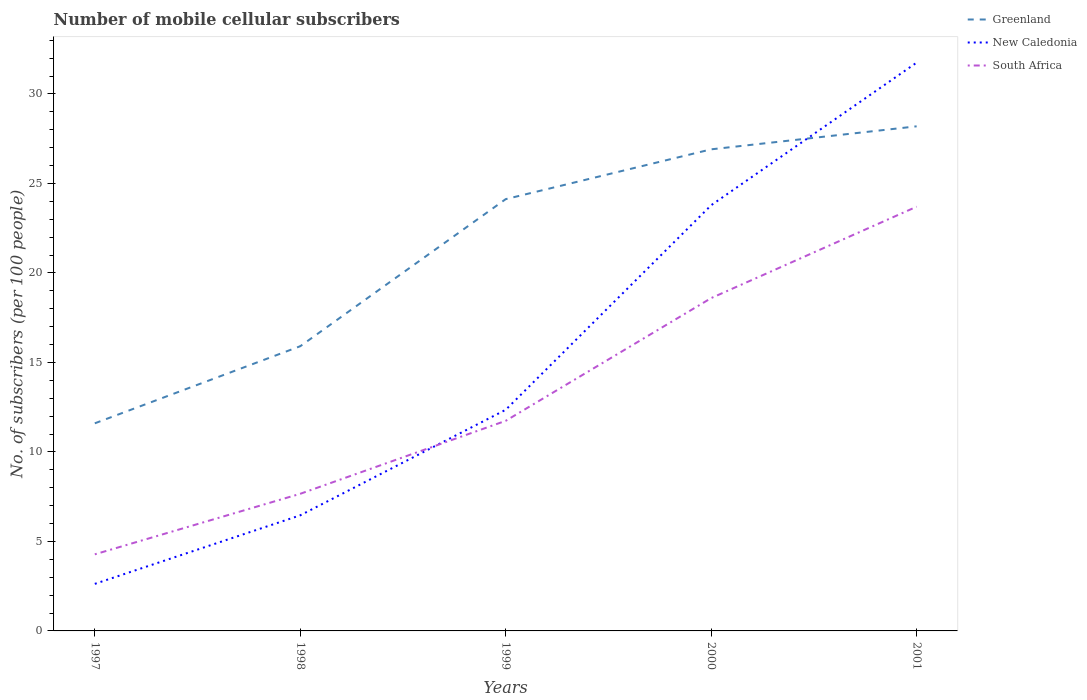Does the line corresponding to South Africa intersect with the line corresponding to Greenland?
Provide a short and direct response. No. Is the number of lines equal to the number of legend labels?
Your response must be concise. Yes. Across all years, what is the maximum number of mobile cellular subscribers in New Caledonia?
Ensure brevity in your answer.  2.63. In which year was the number of mobile cellular subscribers in South Africa maximum?
Ensure brevity in your answer.  1997. What is the total number of mobile cellular subscribers in Greenland in the graph?
Your answer should be very brief. -12.52. What is the difference between the highest and the second highest number of mobile cellular subscribers in New Caledonia?
Ensure brevity in your answer.  29.12. Is the number of mobile cellular subscribers in South Africa strictly greater than the number of mobile cellular subscribers in Greenland over the years?
Provide a short and direct response. Yes. How many lines are there?
Your answer should be very brief. 3. How many years are there in the graph?
Make the answer very short. 5. Are the values on the major ticks of Y-axis written in scientific E-notation?
Your response must be concise. No. Does the graph contain any zero values?
Give a very brief answer. No. Does the graph contain grids?
Offer a terse response. No. How are the legend labels stacked?
Offer a terse response. Vertical. What is the title of the graph?
Keep it short and to the point. Number of mobile cellular subscribers. Does "Chad" appear as one of the legend labels in the graph?
Offer a very short reply. No. What is the label or title of the X-axis?
Your answer should be compact. Years. What is the label or title of the Y-axis?
Your response must be concise. No. of subscribers (per 100 people). What is the No. of subscribers (per 100 people) of Greenland in 1997?
Your answer should be compact. 11.6. What is the No. of subscribers (per 100 people) of New Caledonia in 1997?
Provide a short and direct response. 2.63. What is the No. of subscribers (per 100 people) of South Africa in 1997?
Provide a short and direct response. 4.28. What is the No. of subscribers (per 100 people) in Greenland in 1998?
Your answer should be very brief. 15.91. What is the No. of subscribers (per 100 people) of New Caledonia in 1998?
Your answer should be compact. 6.46. What is the No. of subscribers (per 100 people) in South Africa in 1998?
Provide a short and direct response. 7.66. What is the No. of subscribers (per 100 people) of Greenland in 1999?
Offer a terse response. 24.12. What is the No. of subscribers (per 100 people) in New Caledonia in 1999?
Give a very brief answer. 12.35. What is the No. of subscribers (per 100 people) of South Africa in 1999?
Your response must be concise. 11.74. What is the No. of subscribers (per 100 people) of Greenland in 2000?
Make the answer very short. 26.91. What is the No. of subscribers (per 100 people) in New Caledonia in 2000?
Provide a short and direct response. 23.78. What is the No. of subscribers (per 100 people) in South Africa in 2000?
Make the answer very short. 18.59. What is the No. of subscribers (per 100 people) in Greenland in 2001?
Give a very brief answer. 28.19. What is the No. of subscribers (per 100 people) of New Caledonia in 2001?
Provide a short and direct response. 31.75. What is the No. of subscribers (per 100 people) of South Africa in 2001?
Offer a terse response. 23.7. Across all years, what is the maximum No. of subscribers (per 100 people) of Greenland?
Provide a short and direct response. 28.19. Across all years, what is the maximum No. of subscribers (per 100 people) of New Caledonia?
Your response must be concise. 31.75. Across all years, what is the maximum No. of subscribers (per 100 people) in South Africa?
Give a very brief answer. 23.7. Across all years, what is the minimum No. of subscribers (per 100 people) of Greenland?
Give a very brief answer. 11.6. Across all years, what is the minimum No. of subscribers (per 100 people) of New Caledonia?
Ensure brevity in your answer.  2.63. Across all years, what is the minimum No. of subscribers (per 100 people) of South Africa?
Ensure brevity in your answer.  4.28. What is the total No. of subscribers (per 100 people) in Greenland in the graph?
Provide a succinct answer. 106.72. What is the total No. of subscribers (per 100 people) in New Caledonia in the graph?
Ensure brevity in your answer.  76.97. What is the total No. of subscribers (per 100 people) in South Africa in the graph?
Provide a succinct answer. 65.97. What is the difference between the No. of subscribers (per 100 people) in Greenland in 1997 and that in 1998?
Ensure brevity in your answer.  -4.31. What is the difference between the No. of subscribers (per 100 people) of New Caledonia in 1997 and that in 1998?
Provide a succinct answer. -3.83. What is the difference between the No. of subscribers (per 100 people) of South Africa in 1997 and that in 1998?
Provide a short and direct response. -3.38. What is the difference between the No. of subscribers (per 100 people) of Greenland in 1997 and that in 1999?
Keep it short and to the point. -12.52. What is the difference between the No. of subscribers (per 100 people) in New Caledonia in 1997 and that in 1999?
Keep it short and to the point. -9.73. What is the difference between the No. of subscribers (per 100 people) of South Africa in 1997 and that in 1999?
Your answer should be very brief. -7.46. What is the difference between the No. of subscribers (per 100 people) of Greenland in 1997 and that in 2000?
Make the answer very short. -15.31. What is the difference between the No. of subscribers (per 100 people) in New Caledonia in 1997 and that in 2000?
Keep it short and to the point. -21.15. What is the difference between the No. of subscribers (per 100 people) in South Africa in 1997 and that in 2000?
Keep it short and to the point. -14.32. What is the difference between the No. of subscribers (per 100 people) in Greenland in 1997 and that in 2001?
Ensure brevity in your answer.  -16.59. What is the difference between the No. of subscribers (per 100 people) in New Caledonia in 1997 and that in 2001?
Provide a short and direct response. -29.12. What is the difference between the No. of subscribers (per 100 people) of South Africa in 1997 and that in 2001?
Your response must be concise. -19.42. What is the difference between the No. of subscribers (per 100 people) of Greenland in 1998 and that in 1999?
Offer a very short reply. -8.22. What is the difference between the No. of subscribers (per 100 people) in New Caledonia in 1998 and that in 1999?
Make the answer very short. -5.9. What is the difference between the No. of subscribers (per 100 people) of South Africa in 1998 and that in 1999?
Make the answer very short. -4.08. What is the difference between the No. of subscribers (per 100 people) of Greenland in 1998 and that in 2000?
Offer a terse response. -11. What is the difference between the No. of subscribers (per 100 people) of New Caledonia in 1998 and that in 2000?
Your answer should be very brief. -17.32. What is the difference between the No. of subscribers (per 100 people) in South Africa in 1998 and that in 2000?
Ensure brevity in your answer.  -10.93. What is the difference between the No. of subscribers (per 100 people) of Greenland in 1998 and that in 2001?
Keep it short and to the point. -12.29. What is the difference between the No. of subscribers (per 100 people) in New Caledonia in 1998 and that in 2001?
Provide a short and direct response. -25.29. What is the difference between the No. of subscribers (per 100 people) of South Africa in 1998 and that in 2001?
Make the answer very short. -16.04. What is the difference between the No. of subscribers (per 100 people) in Greenland in 1999 and that in 2000?
Give a very brief answer. -2.78. What is the difference between the No. of subscribers (per 100 people) in New Caledonia in 1999 and that in 2000?
Ensure brevity in your answer.  -11.43. What is the difference between the No. of subscribers (per 100 people) in South Africa in 1999 and that in 2000?
Offer a terse response. -6.86. What is the difference between the No. of subscribers (per 100 people) in Greenland in 1999 and that in 2001?
Your answer should be compact. -4.07. What is the difference between the No. of subscribers (per 100 people) in New Caledonia in 1999 and that in 2001?
Ensure brevity in your answer.  -19.39. What is the difference between the No. of subscribers (per 100 people) in South Africa in 1999 and that in 2001?
Offer a terse response. -11.96. What is the difference between the No. of subscribers (per 100 people) in Greenland in 2000 and that in 2001?
Your response must be concise. -1.29. What is the difference between the No. of subscribers (per 100 people) in New Caledonia in 2000 and that in 2001?
Make the answer very short. -7.97. What is the difference between the No. of subscribers (per 100 people) of South Africa in 2000 and that in 2001?
Your answer should be very brief. -5.11. What is the difference between the No. of subscribers (per 100 people) of Greenland in 1997 and the No. of subscribers (per 100 people) of New Caledonia in 1998?
Your answer should be very brief. 5.14. What is the difference between the No. of subscribers (per 100 people) of Greenland in 1997 and the No. of subscribers (per 100 people) of South Africa in 1998?
Provide a short and direct response. 3.94. What is the difference between the No. of subscribers (per 100 people) in New Caledonia in 1997 and the No. of subscribers (per 100 people) in South Africa in 1998?
Offer a terse response. -5.03. What is the difference between the No. of subscribers (per 100 people) of Greenland in 1997 and the No. of subscribers (per 100 people) of New Caledonia in 1999?
Make the answer very short. -0.76. What is the difference between the No. of subscribers (per 100 people) of Greenland in 1997 and the No. of subscribers (per 100 people) of South Africa in 1999?
Ensure brevity in your answer.  -0.14. What is the difference between the No. of subscribers (per 100 people) of New Caledonia in 1997 and the No. of subscribers (per 100 people) of South Africa in 1999?
Give a very brief answer. -9.11. What is the difference between the No. of subscribers (per 100 people) in Greenland in 1997 and the No. of subscribers (per 100 people) in New Caledonia in 2000?
Offer a terse response. -12.18. What is the difference between the No. of subscribers (per 100 people) in Greenland in 1997 and the No. of subscribers (per 100 people) in South Africa in 2000?
Provide a short and direct response. -7. What is the difference between the No. of subscribers (per 100 people) of New Caledonia in 1997 and the No. of subscribers (per 100 people) of South Africa in 2000?
Give a very brief answer. -15.97. What is the difference between the No. of subscribers (per 100 people) of Greenland in 1997 and the No. of subscribers (per 100 people) of New Caledonia in 2001?
Your answer should be compact. -20.15. What is the difference between the No. of subscribers (per 100 people) in Greenland in 1997 and the No. of subscribers (per 100 people) in South Africa in 2001?
Ensure brevity in your answer.  -12.1. What is the difference between the No. of subscribers (per 100 people) of New Caledonia in 1997 and the No. of subscribers (per 100 people) of South Africa in 2001?
Make the answer very short. -21.07. What is the difference between the No. of subscribers (per 100 people) of Greenland in 1998 and the No. of subscribers (per 100 people) of New Caledonia in 1999?
Provide a succinct answer. 3.55. What is the difference between the No. of subscribers (per 100 people) in Greenland in 1998 and the No. of subscribers (per 100 people) in South Africa in 1999?
Offer a very short reply. 4.17. What is the difference between the No. of subscribers (per 100 people) in New Caledonia in 1998 and the No. of subscribers (per 100 people) in South Africa in 1999?
Offer a terse response. -5.28. What is the difference between the No. of subscribers (per 100 people) of Greenland in 1998 and the No. of subscribers (per 100 people) of New Caledonia in 2000?
Keep it short and to the point. -7.88. What is the difference between the No. of subscribers (per 100 people) in Greenland in 1998 and the No. of subscribers (per 100 people) in South Africa in 2000?
Provide a short and direct response. -2.69. What is the difference between the No. of subscribers (per 100 people) of New Caledonia in 1998 and the No. of subscribers (per 100 people) of South Africa in 2000?
Offer a very short reply. -12.14. What is the difference between the No. of subscribers (per 100 people) of Greenland in 1998 and the No. of subscribers (per 100 people) of New Caledonia in 2001?
Ensure brevity in your answer.  -15.84. What is the difference between the No. of subscribers (per 100 people) in Greenland in 1998 and the No. of subscribers (per 100 people) in South Africa in 2001?
Offer a very short reply. -7.79. What is the difference between the No. of subscribers (per 100 people) of New Caledonia in 1998 and the No. of subscribers (per 100 people) of South Africa in 2001?
Your answer should be very brief. -17.24. What is the difference between the No. of subscribers (per 100 people) of Greenland in 1999 and the No. of subscribers (per 100 people) of New Caledonia in 2000?
Provide a short and direct response. 0.34. What is the difference between the No. of subscribers (per 100 people) of Greenland in 1999 and the No. of subscribers (per 100 people) of South Africa in 2000?
Your response must be concise. 5.53. What is the difference between the No. of subscribers (per 100 people) of New Caledonia in 1999 and the No. of subscribers (per 100 people) of South Africa in 2000?
Your answer should be very brief. -6.24. What is the difference between the No. of subscribers (per 100 people) of Greenland in 1999 and the No. of subscribers (per 100 people) of New Caledonia in 2001?
Make the answer very short. -7.63. What is the difference between the No. of subscribers (per 100 people) in Greenland in 1999 and the No. of subscribers (per 100 people) in South Africa in 2001?
Give a very brief answer. 0.42. What is the difference between the No. of subscribers (per 100 people) of New Caledonia in 1999 and the No. of subscribers (per 100 people) of South Africa in 2001?
Your answer should be very brief. -11.35. What is the difference between the No. of subscribers (per 100 people) in Greenland in 2000 and the No. of subscribers (per 100 people) in New Caledonia in 2001?
Offer a terse response. -4.84. What is the difference between the No. of subscribers (per 100 people) of Greenland in 2000 and the No. of subscribers (per 100 people) of South Africa in 2001?
Your answer should be very brief. 3.2. What is the difference between the No. of subscribers (per 100 people) in New Caledonia in 2000 and the No. of subscribers (per 100 people) in South Africa in 2001?
Offer a very short reply. 0.08. What is the average No. of subscribers (per 100 people) of Greenland per year?
Your answer should be compact. 21.34. What is the average No. of subscribers (per 100 people) in New Caledonia per year?
Make the answer very short. 15.39. What is the average No. of subscribers (per 100 people) of South Africa per year?
Make the answer very short. 13.19. In the year 1997, what is the difference between the No. of subscribers (per 100 people) of Greenland and No. of subscribers (per 100 people) of New Caledonia?
Give a very brief answer. 8.97. In the year 1997, what is the difference between the No. of subscribers (per 100 people) in Greenland and No. of subscribers (per 100 people) in South Africa?
Your answer should be very brief. 7.32. In the year 1997, what is the difference between the No. of subscribers (per 100 people) of New Caledonia and No. of subscribers (per 100 people) of South Africa?
Provide a succinct answer. -1.65. In the year 1998, what is the difference between the No. of subscribers (per 100 people) of Greenland and No. of subscribers (per 100 people) of New Caledonia?
Provide a succinct answer. 9.45. In the year 1998, what is the difference between the No. of subscribers (per 100 people) in Greenland and No. of subscribers (per 100 people) in South Africa?
Provide a short and direct response. 8.24. In the year 1998, what is the difference between the No. of subscribers (per 100 people) of New Caledonia and No. of subscribers (per 100 people) of South Africa?
Your answer should be compact. -1.2. In the year 1999, what is the difference between the No. of subscribers (per 100 people) in Greenland and No. of subscribers (per 100 people) in New Caledonia?
Offer a terse response. 11.77. In the year 1999, what is the difference between the No. of subscribers (per 100 people) of Greenland and No. of subscribers (per 100 people) of South Africa?
Provide a succinct answer. 12.38. In the year 1999, what is the difference between the No. of subscribers (per 100 people) of New Caledonia and No. of subscribers (per 100 people) of South Africa?
Keep it short and to the point. 0.62. In the year 2000, what is the difference between the No. of subscribers (per 100 people) of Greenland and No. of subscribers (per 100 people) of New Caledonia?
Give a very brief answer. 3.12. In the year 2000, what is the difference between the No. of subscribers (per 100 people) of Greenland and No. of subscribers (per 100 people) of South Africa?
Your answer should be very brief. 8.31. In the year 2000, what is the difference between the No. of subscribers (per 100 people) of New Caledonia and No. of subscribers (per 100 people) of South Africa?
Your answer should be compact. 5.19. In the year 2001, what is the difference between the No. of subscribers (per 100 people) in Greenland and No. of subscribers (per 100 people) in New Caledonia?
Your answer should be very brief. -3.56. In the year 2001, what is the difference between the No. of subscribers (per 100 people) of Greenland and No. of subscribers (per 100 people) of South Africa?
Provide a short and direct response. 4.49. In the year 2001, what is the difference between the No. of subscribers (per 100 people) in New Caledonia and No. of subscribers (per 100 people) in South Africa?
Provide a short and direct response. 8.05. What is the ratio of the No. of subscribers (per 100 people) in Greenland in 1997 to that in 1998?
Offer a terse response. 0.73. What is the ratio of the No. of subscribers (per 100 people) of New Caledonia in 1997 to that in 1998?
Your answer should be compact. 0.41. What is the ratio of the No. of subscribers (per 100 people) in South Africa in 1997 to that in 1998?
Provide a short and direct response. 0.56. What is the ratio of the No. of subscribers (per 100 people) in Greenland in 1997 to that in 1999?
Your response must be concise. 0.48. What is the ratio of the No. of subscribers (per 100 people) of New Caledonia in 1997 to that in 1999?
Keep it short and to the point. 0.21. What is the ratio of the No. of subscribers (per 100 people) of South Africa in 1997 to that in 1999?
Give a very brief answer. 0.36. What is the ratio of the No. of subscribers (per 100 people) of Greenland in 1997 to that in 2000?
Provide a succinct answer. 0.43. What is the ratio of the No. of subscribers (per 100 people) in New Caledonia in 1997 to that in 2000?
Give a very brief answer. 0.11. What is the ratio of the No. of subscribers (per 100 people) of South Africa in 1997 to that in 2000?
Offer a very short reply. 0.23. What is the ratio of the No. of subscribers (per 100 people) in Greenland in 1997 to that in 2001?
Make the answer very short. 0.41. What is the ratio of the No. of subscribers (per 100 people) of New Caledonia in 1997 to that in 2001?
Provide a succinct answer. 0.08. What is the ratio of the No. of subscribers (per 100 people) in South Africa in 1997 to that in 2001?
Keep it short and to the point. 0.18. What is the ratio of the No. of subscribers (per 100 people) of Greenland in 1998 to that in 1999?
Provide a short and direct response. 0.66. What is the ratio of the No. of subscribers (per 100 people) in New Caledonia in 1998 to that in 1999?
Make the answer very short. 0.52. What is the ratio of the No. of subscribers (per 100 people) in South Africa in 1998 to that in 1999?
Your response must be concise. 0.65. What is the ratio of the No. of subscribers (per 100 people) in Greenland in 1998 to that in 2000?
Your answer should be compact. 0.59. What is the ratio of the No. of subscribers (per 100 people) of New Caledonia in 1998 to that in 2000?
Offer a very short reply. 0.27. What is the ratio of the No. of subscribers (per 100 people) in South Africa in 1998 to that in 2000?
Offer a terse response. 0.41. What is the ratio of the No. of subscribers (per 100 people) of Greenland in 1998 to that in 2001?
Provide a short and direct response. 0.56. What is the ratio of the No. of subscribers (per 100 people) of New Caledonia in 1998 to that in 2001?
Provide a short and direct response. 0.2. What is the ratio of the No. of subscribers (per 100 people) in South Africa in 1998 to that in 2001?
Offer a terse response. 0.32. What is the ratio of the No. of subscribers (per 100 people) of Greenland in 1999 to that in 2000?
Give a very brief answer. 0.9. What is the ratio of the No. of subscribers (per 100 people) of New Caledonia in 1999 to that in 2000?
Your answer should be compact. 0.52. What is the ratio of the No. of subscribers (per 100 people) of South Africa in 1999 to that in 2000?
Make the answer very short. 0.63. What is the ratio of the No. of subscribers (per 100 people) in Greenland in 1999 to that in 2001?
Your response must be concise. 0.86. What is the ratio of the No. of subscribers (per 100 people) of New Caledonia in 1999 to that in 2001?
Provide a short and direct response. 0.39. What is the ratio of the No. of subscribers (per 100 people) in South Africa in 1999 to that in 2001?
Your answer should be very brief. 0.5. What is the ratio of the No. of subscribers (per 100 people) of Greenland in 2000 to that in 2001?
Your answer should be compact. 0.95. What is the ratio of the No. of subscribers (per 100 people) of New Caledonia in 2000 to that in 2001?
Keep it short and to the point. 0.75. What is the ratio of the No. of subscribers (per 100 people) of South Africa in 2000 to that in 2001?
Your response must be concise. 0.78. What is the difference between the highest and the second highest No. of subscribers (per 100 people) in Greenland?
Offer a terse response. 1.29. What is the difference between the highest and the second highest No. of subscribers (per 100 people) in New Caledonia?
Ensure brevity in your answer.  7.97. What is the difference between the highest and the second highest No. of subscribers (per 100 people) of South Africa?
Your response must be concise. 5.11. What is the difference between the highest and the lowest No. of subscribers (per 100 people) of Greenland?
Your response must be concise. 16.59. What is the difference between the highest and the lowest No. of subscribers (per 100 people) in New Caledonia?
Make the answer very short. 29.12. What is the difference between the highest and the lowest No. of subscribers (per 100 people) in South Africa?
Provide a short and direct response. 19.42. 